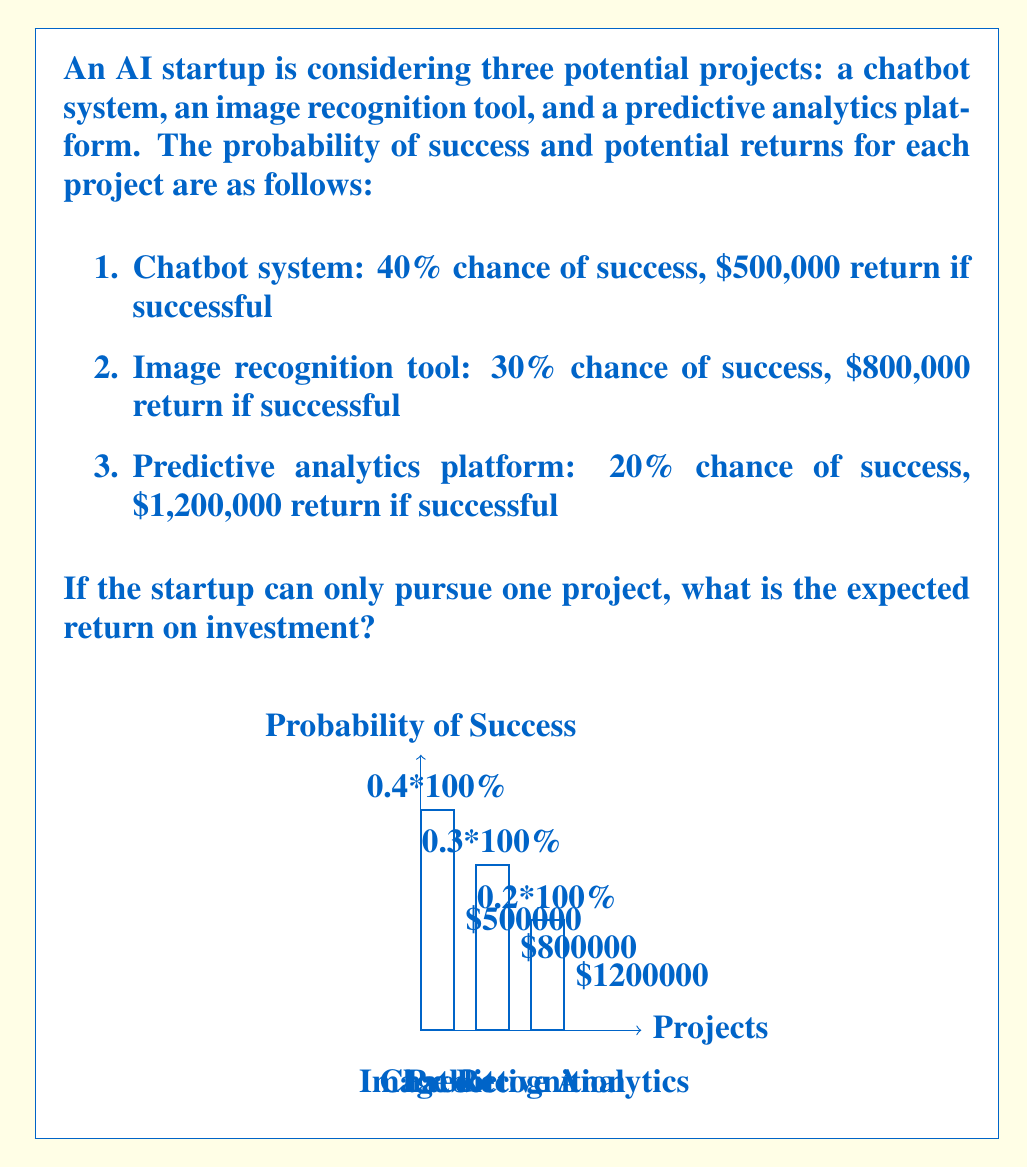Help me with this question. To determine the expected return on investment for the AI startup, we need to calculate the expected value for each project and then choose the highest one. The expected value is calculated by multiplying the probability of success by the potential return.

Let's calculate the expected value for each project:

1. Chatbot system:
   $EV_{chatbot} = 0.40 \times \$500,000 = \$200,000$

2. Image recognition tool:
   $EV_{image} = 0.30 \times \$800,000 = \$240,000$

3. Predictive analytics platform:
   $EV_{predictive} = 0.20 \times \$1,200,000 = \$240,000$

Now, we compare the expected values:

$$\begin{align}
EV_{chatbot} &= \$200,000 \\
EV_{image} &= \$240,000 \\
EV_{predictive} &= \$240,000
\end{align}$$

We can see that both the image recognition tool and the predictive analytics platform have the highest expected value of $240,000. Since the startup can only pursue one project, they should choose either the image recognition tool or the predictive analytics platform, as both have the same expected return on investment.

Therefore, the expected return on investment for the AI startup is $240,000.
Answer: $240,000 